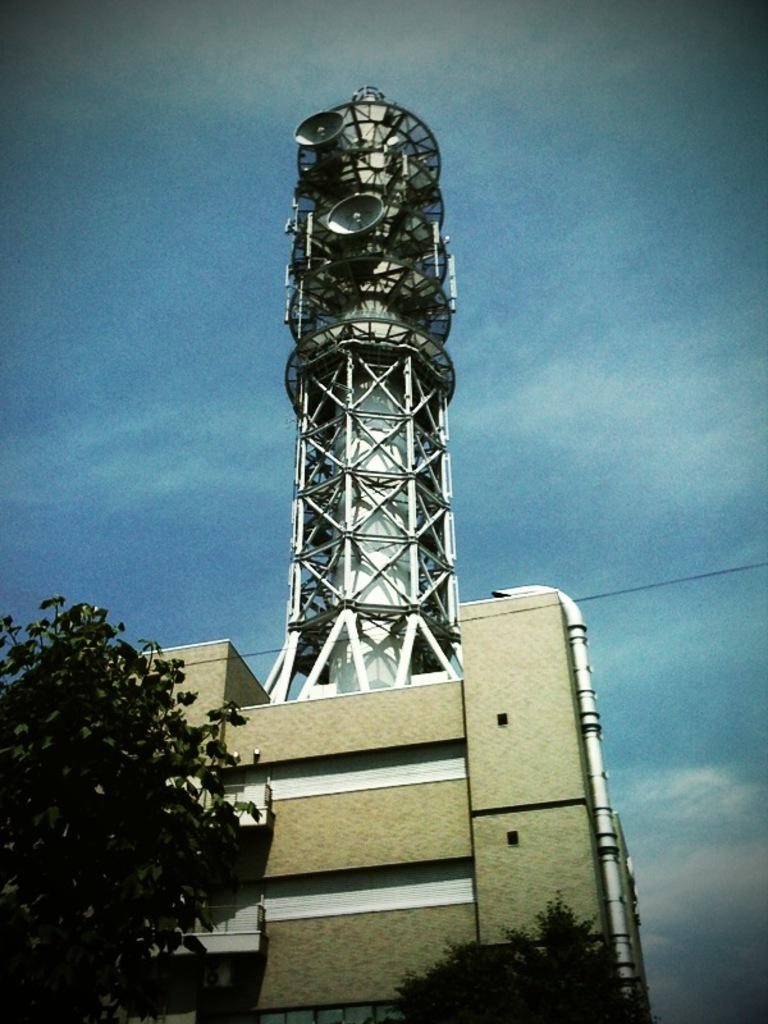What type of vegetation can be seen in the image? There are trees in the image. What type of structure is present in the image? There is a building and a tower in the image. What man-made objects can be seen in the image? There is a pipe and wires in the image. What color is the sky in the background of the image? The sky is blue in the background of the image. What type of plastic item can be seen in the image? There is no plastic item present in the image. Can you tell me how many buttons are on the tower in the image? There are no buttons present on the tower in the image. 